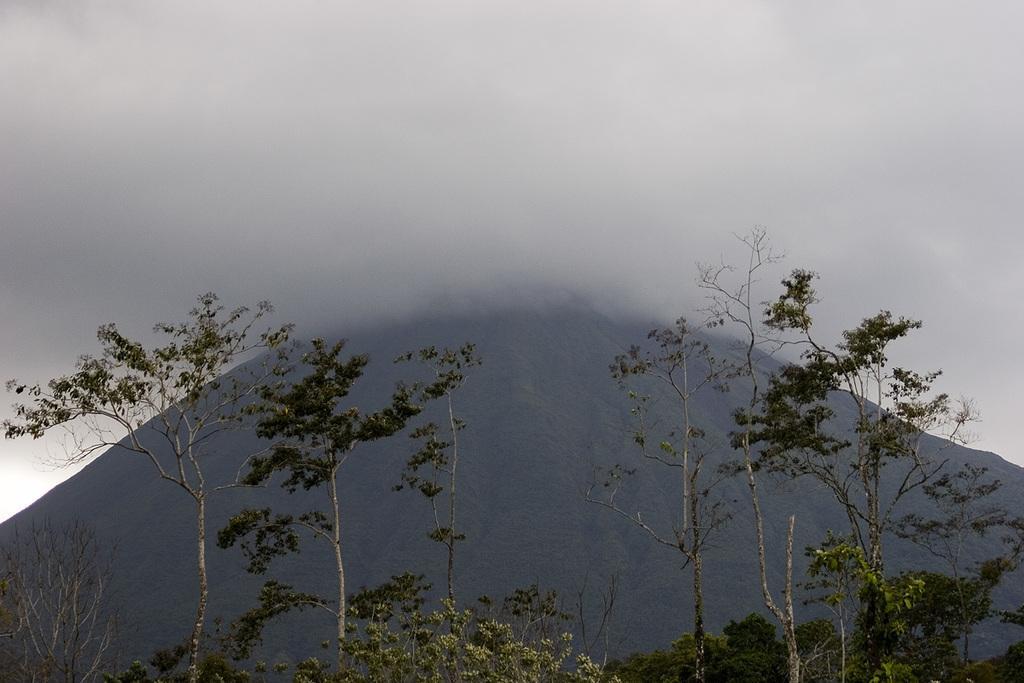Describe this image in one or two sentences. At the bottom, we see the trees. In the background, we see the hill. At the top, we see the sky. 